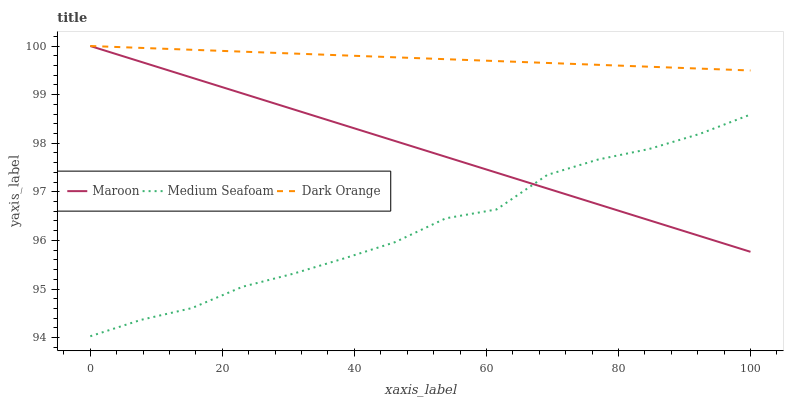Does Medium Seafoam have the minimum area under the curve?
Answer yes or no. Yes. Does Dark Orange have the maximum area under the curve?
Answer yes or no. Yes. Does Maroon have the minimum area under the curve?
Answer yes or no. No. Does Maroon have the maximum area under the curve?
Answer yes or no. No. Is Dark Orange the smoothest?
Answer yes or no. Yes. Is Medium Seafoam the roughest?
Answer yes or no. Yes. Is Maroon the smoothest?
Answer yes or no. No. Is Maroon the roughest?
Answer yes or no. No. Does Medium Seafoam have the lowest value?
Answer yes or no. Yes. Does Maroon have the lowest value?
Answer yes or no. No. Does Maroon have the highest value?
Answer yes or no. Yes. Does Medium Seafoam have the highest value?
Answer yes or no. No. Is Medium Seafoam less than Dark Orange?
Answer yes or no. Yes. Is Dark Orange greater than Medium Seafoam?
Answer yes or no. Yes. Does Maroon intersect Dark Orange?
Answer yes or no. Yes. Is Maroon less than Dark Orange?
Answer yes or no. No. Is Maroon greater than Dark Orange?
Answer yes or no. No. Does Medium Seafoam intersect Dark Orange?
Answer yes or no. No. 